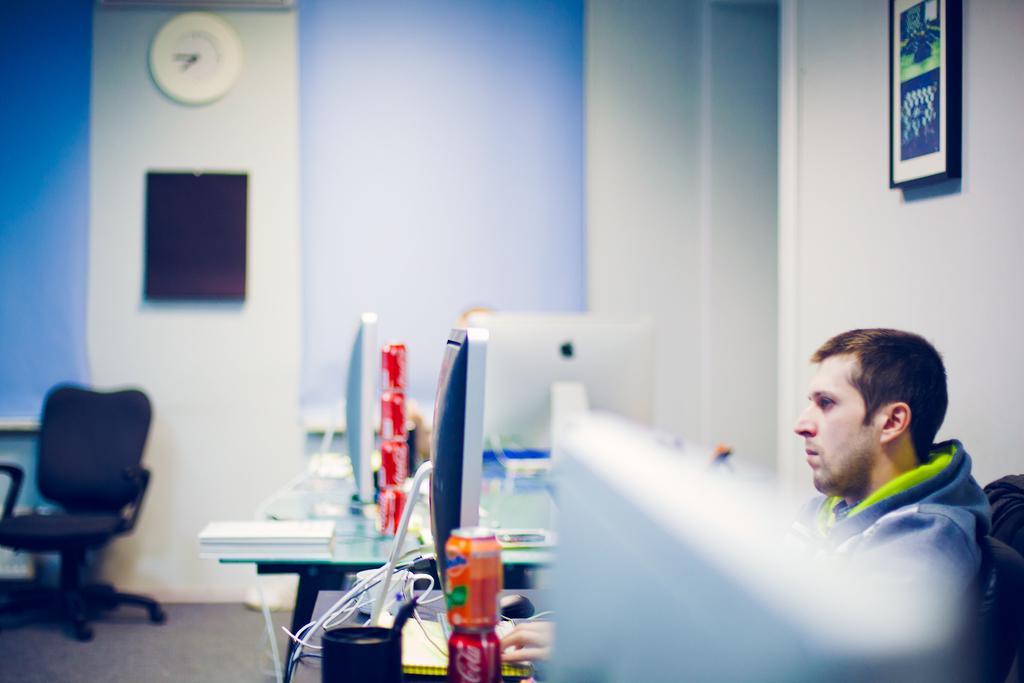Can you describe this image briefly? In this image we can see laptops. There are few objects on a table. At the bottom we can see few objects. On the right side, we can see a wall and a person on a chair. On the wall we can see a photo frame. In the background, we can see a chair and a wall. On the wall there is a black object and a clock. 